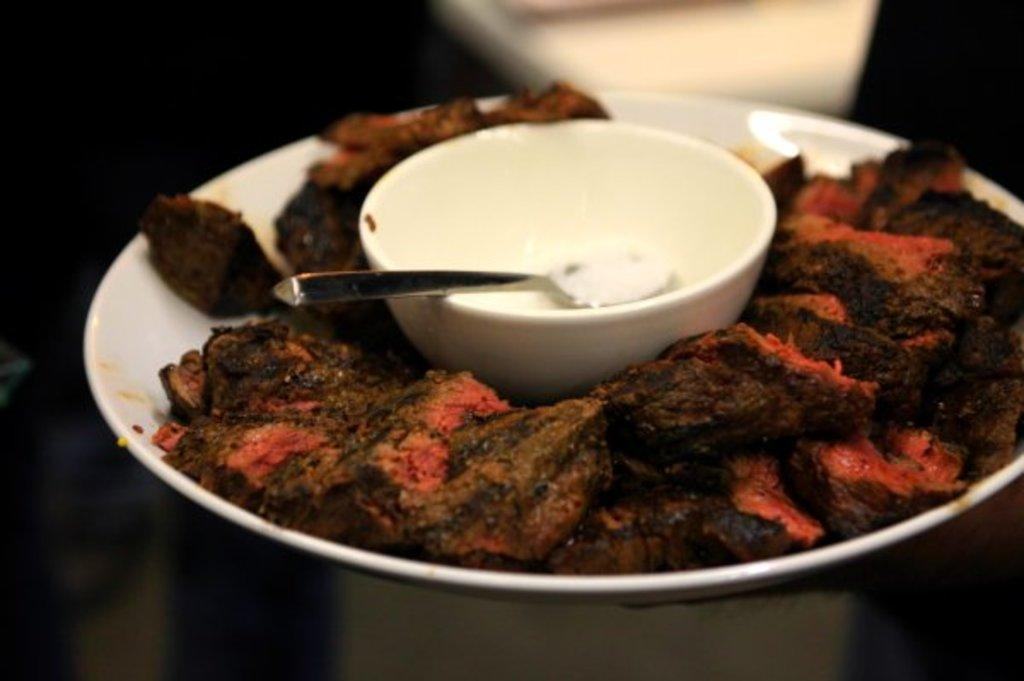What is on the plate that is visible in the image? There is a plate with food items in the image. What is in the bowl that is visible in the image? There is a bowl with a spoon in the image. What type of rake is being used to harvest the corn in the image? There is no rake or corn present in the image. What kind of cloud formation can be seen in the image? There is no cloud formation visible in the image; it only features a plate with food items and a bowl with a spoon. 